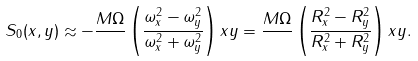<formula> <loc_0><loc_0><loc_500><loc_500>S _ { 0 } ( x , y ) \approx - \frac { M \Omega } { } \left ( \frac { \omega _ { x } ^ { 2 } - \omega _ { y } ^ { 2 } } { \omega _ { x } ^ { 2 } + \omega _ { y } ^ { 2 } } \right ) x y = \frac { M \Omega } { } \left ( \frac { R _ { x } ^ { 2 } - R _ { y } ^ { 2 } } { R _ { x } ^ { 2 } + R _ { y } ^ { 2 } } \right ) x y .</formula> 